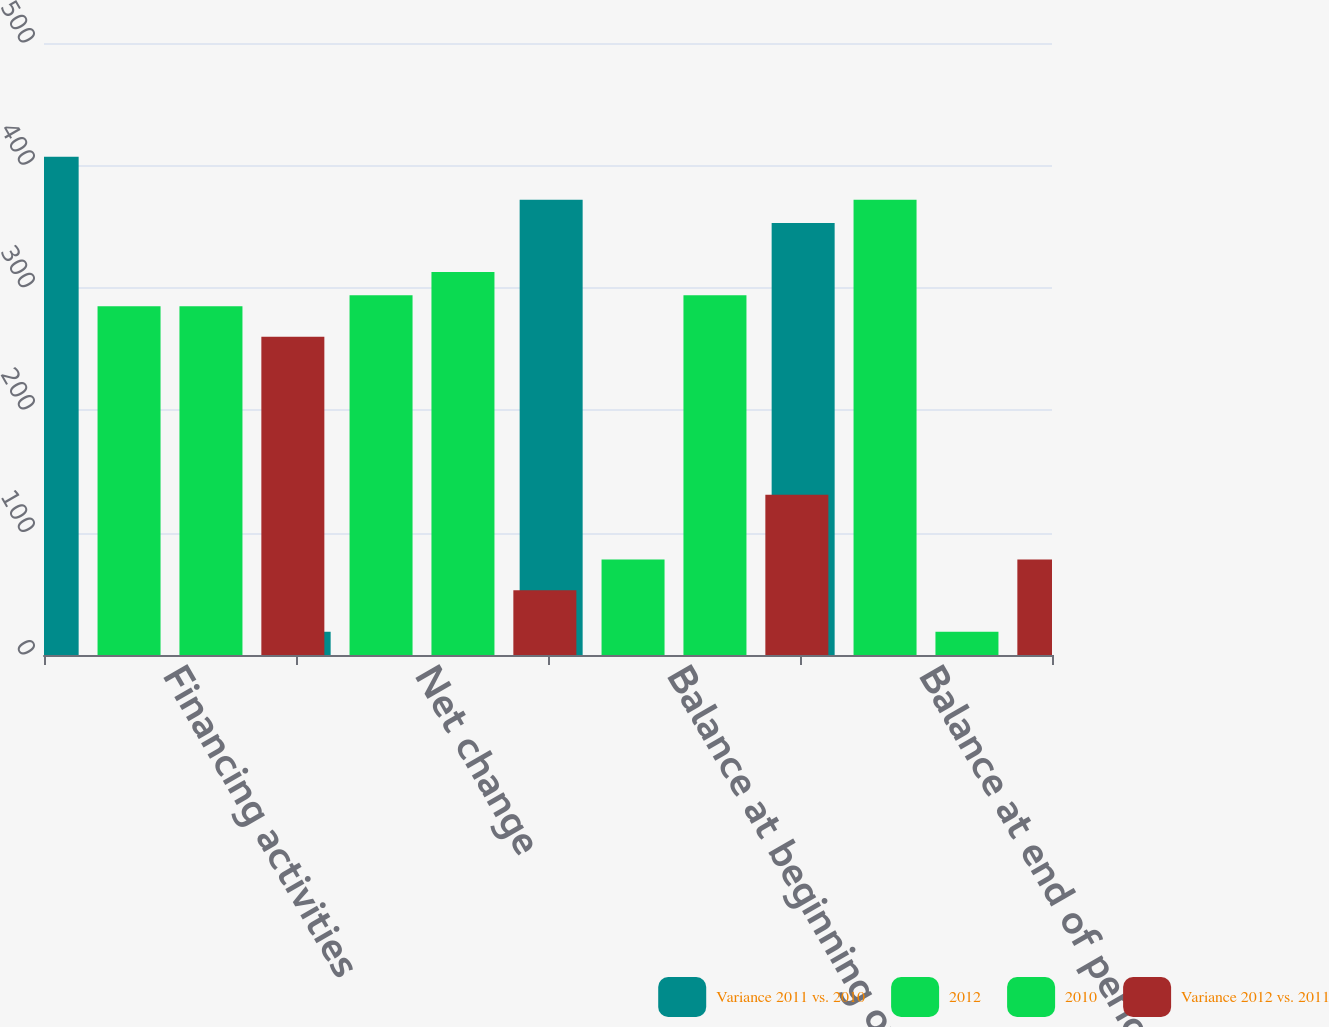Convert chart. <chart><loc_0><loc_0><loc_500><loc_500><stacked_bar_chart><ecel><fcel>Financing activities<fcel>Net change<fcel>Balance at beginning of period<fcel>Balance at end of period<nl><fcel>Variance 2011 vs. 2010<fcel>407<fcel>19<fcel>372<fcel>353<nl><fcel>2012<fcel>285<fcel>294<fcel>78<fcel>372<nl><fcel>2010<fcel>285<fcel>313<fcel>294<fcel>19<nl><fcel>Variance 2012 vs. 2011<fcel>260<fcel>53<fcel>131<fcel>78<nl></chart> 